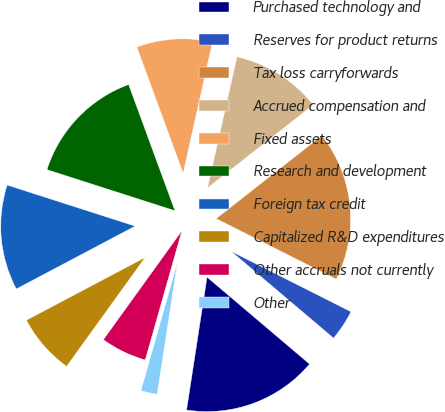<chart> <loc_0><loc_0><loc_500><loc_500><pie_chart><fcel>Purchased technology and<fcel>Reserves for product returns<fcel>Tax loss carryforwards<fcel>Accrued compensation and<fcel>Fixed assets<fcel>Research and development<fcel>Foreign tax credit<fcel>Capitalized R&D expenditures<fcel>Other accruals not currently<fcel>Other<nl><fcel>16.24%<fcel>3.76%<fcel>18.03%<fcel>10.89%<fcel>9.11%<fcel>14.46%<fcel>12.68%<fcel>7.32%<fcel>5.54%<fcel>1.97%<nl></chart> 